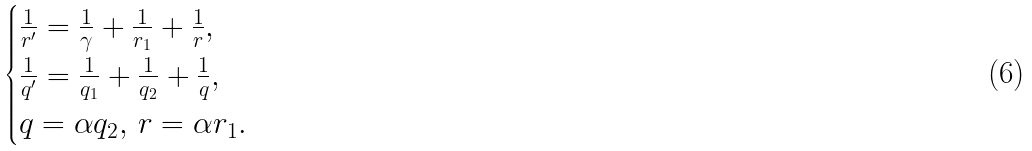<formula> <loc_0><loc_0><loc_500><loc_500>\begin{cases} \frac { 1 } { r ^ { \prime } } = \frac { 1 } { \gamma } + \frac { 1 } { r _ { 1 } } + \frac { 1 } { r } , \\ \frac { 1 } { q ^ { \prime } } = \frac { 1 } { q _ { 1 } } + \frac { 1 } { q _ { 2 } } + \frac { 1 } { q } , \\ q = \alpha q _ { 2 } , \, r = \alpha r _ { 1 } . \end{cases}</formula> 